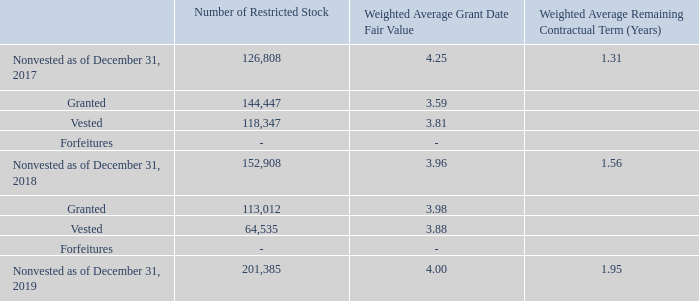NOTE 11 - STOCK CAPITAL (Cont.)
Share-based compensation to employees and to directors: (Cont.)
Restricted Stock:
The Company awards stock and restricted stock to certain employees, officers, directors, and/or service providers. The restricted stock vests in accordance with such conditions and restrictions determined by the GNC Committee. These conditions and restrictions may include the achievement of certain performance goals and/or continued employment with the Company through a specified restricted period. The purchase price (if any) of shares of restricted stock is determined by the GNC Committee. If the performance goals and other restrictions are not attained, the grantee will automatically forfeit their unvested awards of restricted stock to the Company. Compensation expense for restricted stock is based on fair market value at the grant date.
The total compensation expense recorded by the Company in respect of its stock and restricted stock awards to certain employees, officers, directors, and service providers for the year ended December 31, 2019 and 2018 amounted to $392 and $506, respectively.
What is the total compensation expense recorded by the Company for the year ended December 31, 2018? $506. What is the total compensation expense recorded by the Company for the year ended December 31, 2019? $392. Who does the Company award and restrict stock to? Certain employees, officers, directors, and/or service providers. What is the percentage of granted restricted stock in total noninvested stock as of December 31, 2018?
Answer scale should be: percent. 144,447/152,908
Answer: 94.47. What is the percentage change in the number of noninvested restricted stock from 2018 to 2019?
Answer scale should be: percent. (201,385-152,908)/152,908
Answer: 31.7. What is the change in the granted restricted stocks from 2018 to 2019? 113,012-144,447
Answer: -31435. 